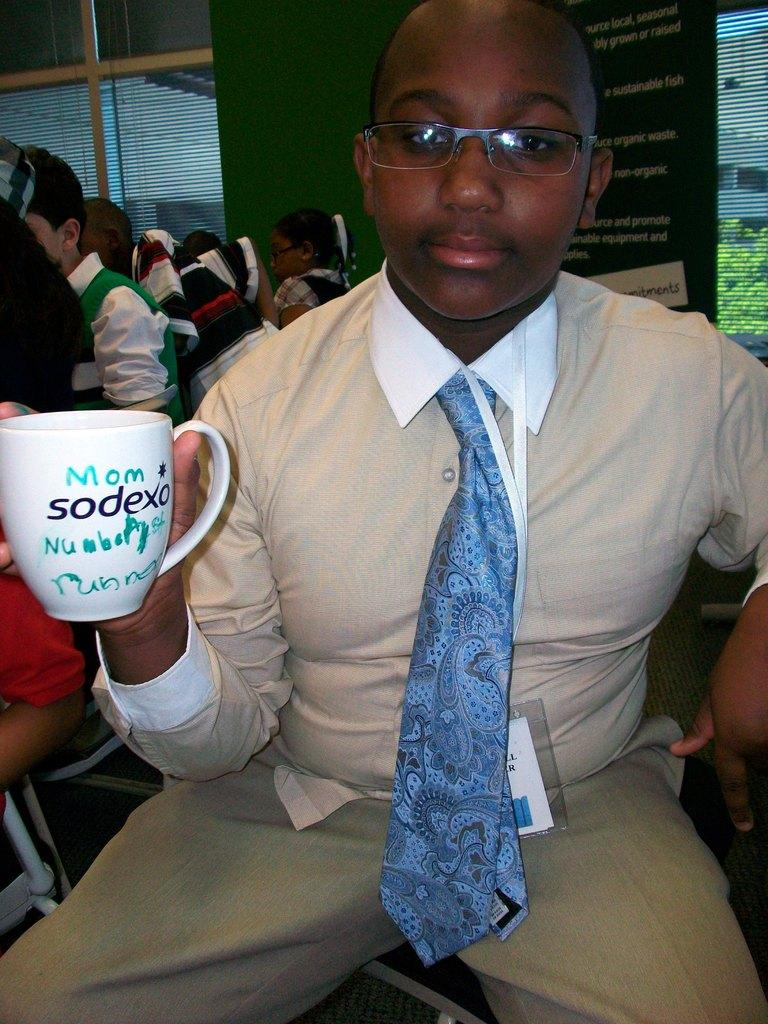What is the person in the foreground of the image doing? The person is sitting on a chair in the image. What is the person holding in the image? The person is holding a cup. Can you describe the setting in the background of the image? There are multiple people sitting in the background of the image. What type of money is the person using to pay for the cup in the image? There is no indication of money or payment in the image; the person is simply holding a cup. 